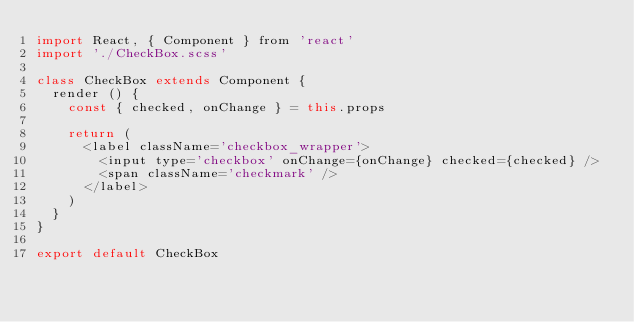Convert code to text. <code><loc_0><loc_0><loc_500><loc_500><_JavaScript_>import React, { Component } from 'react'
import './CheckBox.scss'

class CheckBox extends Component {
  render () {
    const { checked, onChange } = this.props

    return (
      <label className='checkbox_wrapper'>
        <input type='checkbox' onChange={onChange} checked={checked} />
        <span className='checkmark' />
      </label>
    )
  }
}

export default CheckBox
</code> 